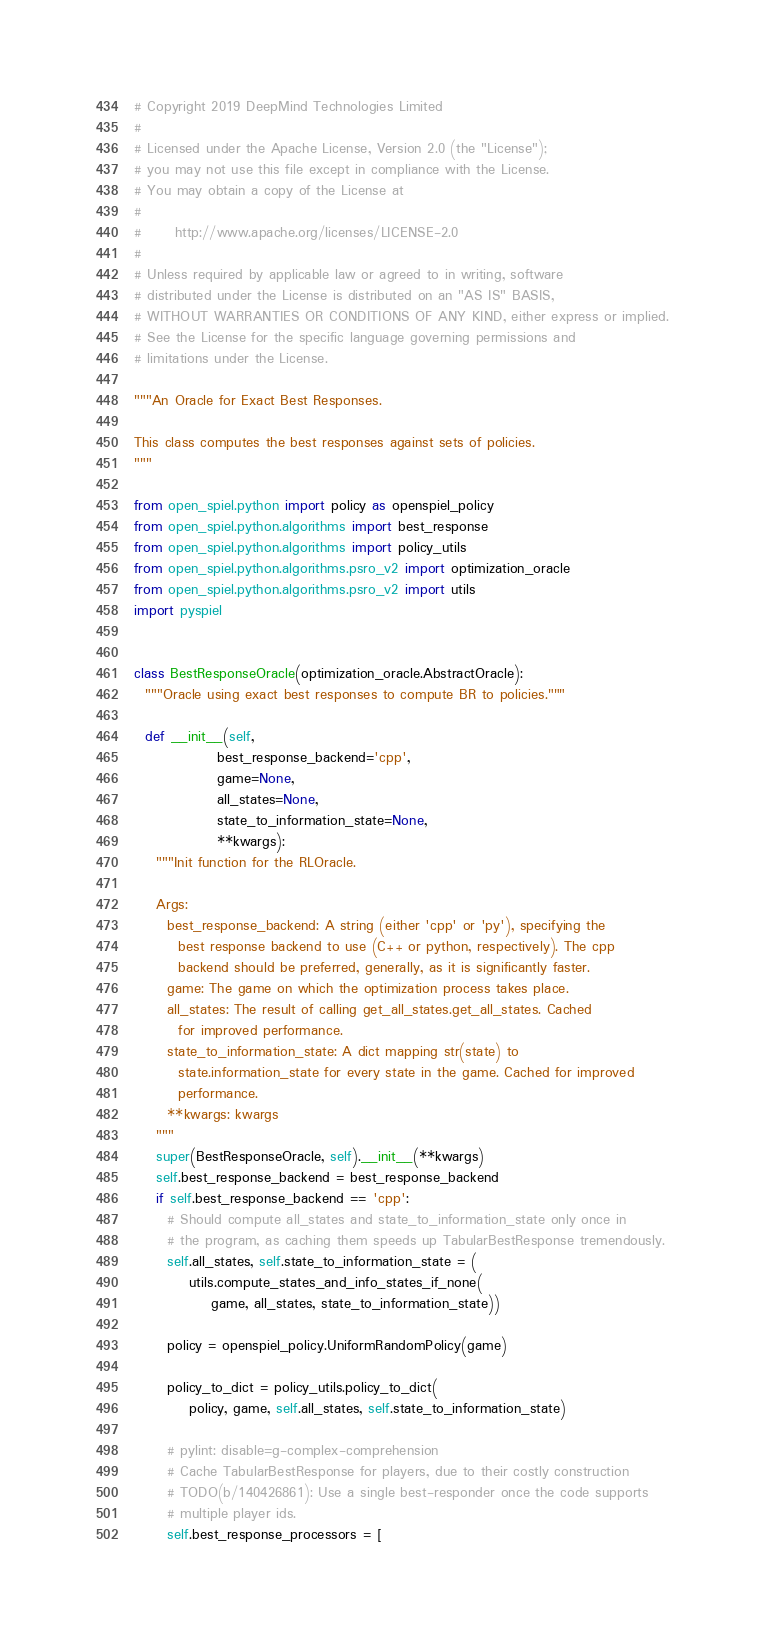Convert code to text. <code><loc_0><loc_0><loc_500><loc_500><_Python_># Copyright 2019 DeepMind Technologies Limited
#
# Licensed under the Apache License, Version 2.0 (the "License");
# you may not use this file except in compliance with the License.
# You may obtain a copy of the License at
#
#      http://www.apache.org/licenses/LICENSE-2.0
#
# Unless required by applicable law or agreed to in writing, software
# distributed under the License is distributed on an "AS IS" BASIS,
# WITHOUT WARRANTIES OR CONDITIONS OF ANY KIND, either express or implied.
# See the License for the specific language governing permissions and
# limitations under the License.

"""An Oracle for Exact Best Responses.

This class computes the best responses against sets of policies.
"""

from open_spiel.python import policy as openspiel_policy
from open_spiel.python.algorithms import best_response
from open_spiel.python.algorithms import policy_utils
from open_spiel.python.algorithms.psro_v2 import optimization_oracle
from open_spiel.python.algorithms.psro_v2 import utils
import pyspiel


class BestResponseOracle(optimization_oracle.AbstractOracle):
  """Oracle using exact best responses to compute BR to policies."""

  def __init__(self,
               best_response_backend='cpp',
               game=None,
               all_states=None,
               state_to_information_state=None,
               **kwargs):
    """Init function for the RLOracle.

    Args:
      best_response_backend: A string (either 'cpp' or 'py'), specifying the
        best response backend to use (C++ or python, respectively). The cpp
        backend should be preferred, generally, as it is significantly faster.
      game: The game on which the optimization process takes place.
      all_states: The result of calling get_all_states.get_all_states. Cached
        for improved performance.
      state_to_information_state: A dict mapping str(state) to
        state.information_state for every state in the game. Cached for improved
        performance.
      **kwargs: kwargs
    """
    super(BestResponseOracle, self).__init__(**kwargs)
    self.best_response_backend = best_response_backend
    if self.best_response_backend == 'cpp':
      # Should compute all_states and state_to_information_state only once in
      # the program, as caching them speeds up TabularBestResponse tremendously.
      self.all_states, self.state_to_information_state = (
          utils.compute_states_and_info_states_if_none(
              game, all_states, state_to_information_state))

      policy = openspiel_policy.UniformRandomPolicy(game)

      policy_to_dict = policy_utils.policy_to_dict(
          policy, game, self.all_states, self.state_to_information_state)

      # pylint: disable=g-complex-comprehension
      # Cache TabularBestResponse for players, due to their costly construction
      # TODO(b/140426861): Use a single best-responder once the code supports
      # multiple player ids.
      self.best_response_processors = [</code> 